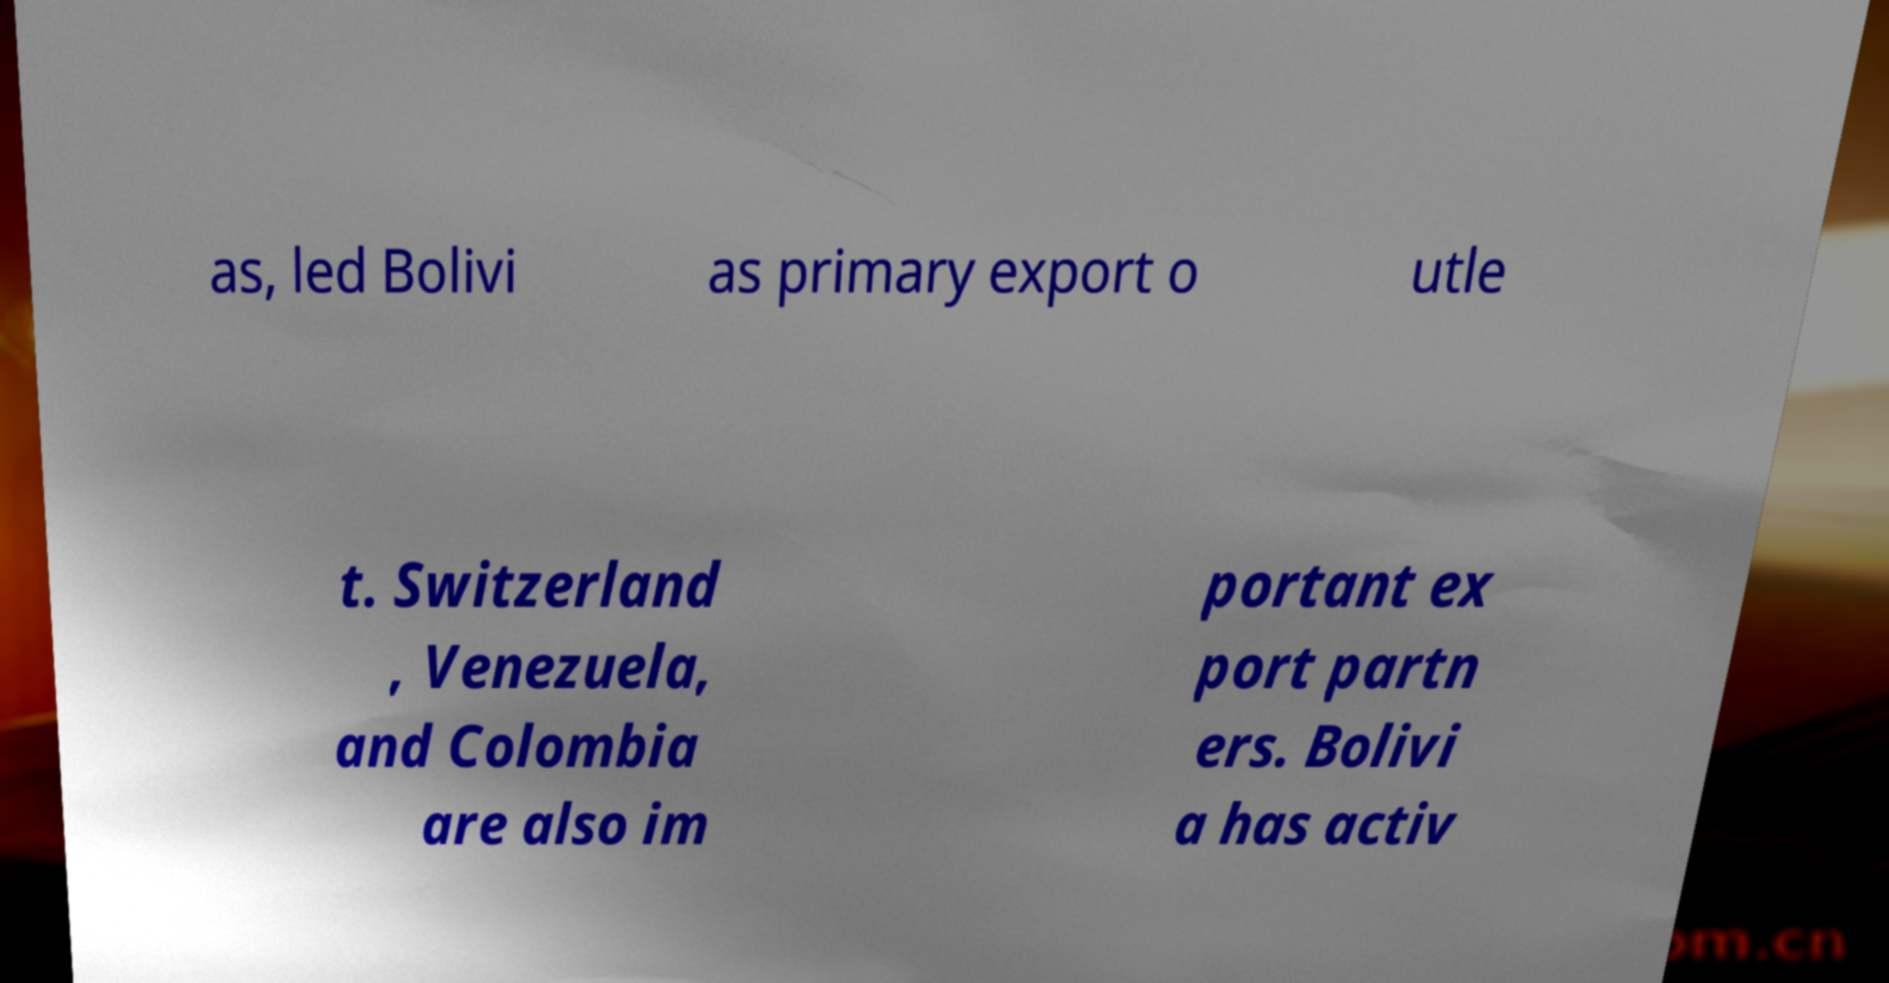Could you extract and type out the text from this image? as, led Bolivi as primary export o utle t. Switzerland , Venezuela, and Colombia are also im portant ex port partn ers. Bolivi a has activ 